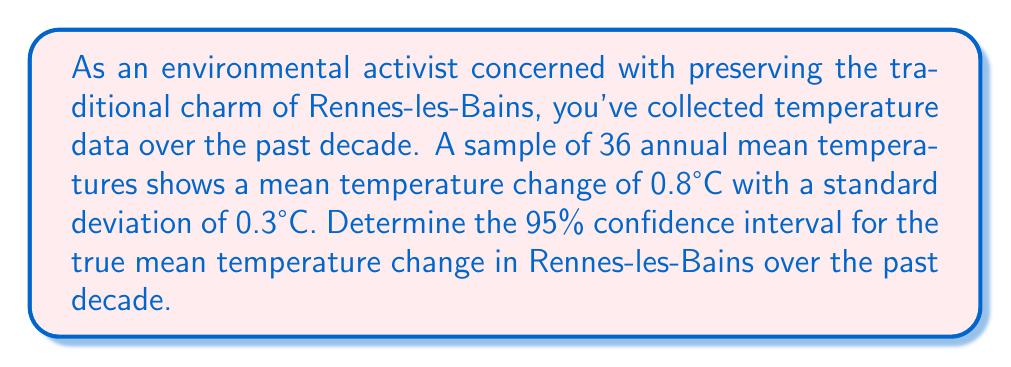What is the answer to this math problem? To calculate the confidence interval, we'll follow these steps:

1. Identify the given information:
   - Sample size: $n = 36$
   - Sample mean: $\bar{x} = 0.8°C$
   - Sample standard deviation: $s = 0.3°C$
   - Confidence level: 95% (α = 0.05)

2. Determine the critical value:
   For a 95% confidence interval with 35 degrees of freedom (n-1), we use the t-distribution. The critical value is $t_{0.025, 35} = 2.030$ (from t-table).

3. Calculate the standard error of the mean:
   $SE = \frac{s}{\sqrt{n}} = \frac{0.3}{\sqrt{36}} = 0.05$

4. Compute the margin of error:
   $E = t_{0.025, 35} \times SE = 2.030 \times 0.05 = 0.1015$

5. Calculate the confidence interval:
   Lower bound: $\bar{x} - E = 0.8 - 0.1015 = 0.6985°C$
   Upper bound: $\bar{x} + E = 0.8 + 0.1015 = 0.9015°C$

Therefore, the 95% confidence interval for the true mean temperature change in Rennes-les-Bains over the past decade is (0.6985°C, 0.9015°C).
Answer: (0.6985°C, 0.9015°C) 